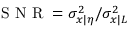Convert formula to latex. <formula><loc_0><loc_0><loc_500><loc_500>S N R = \sigma _ { x | \eta } ^ { 2 } / \sigma _ { x | L } ^ { 2 }</formula> 